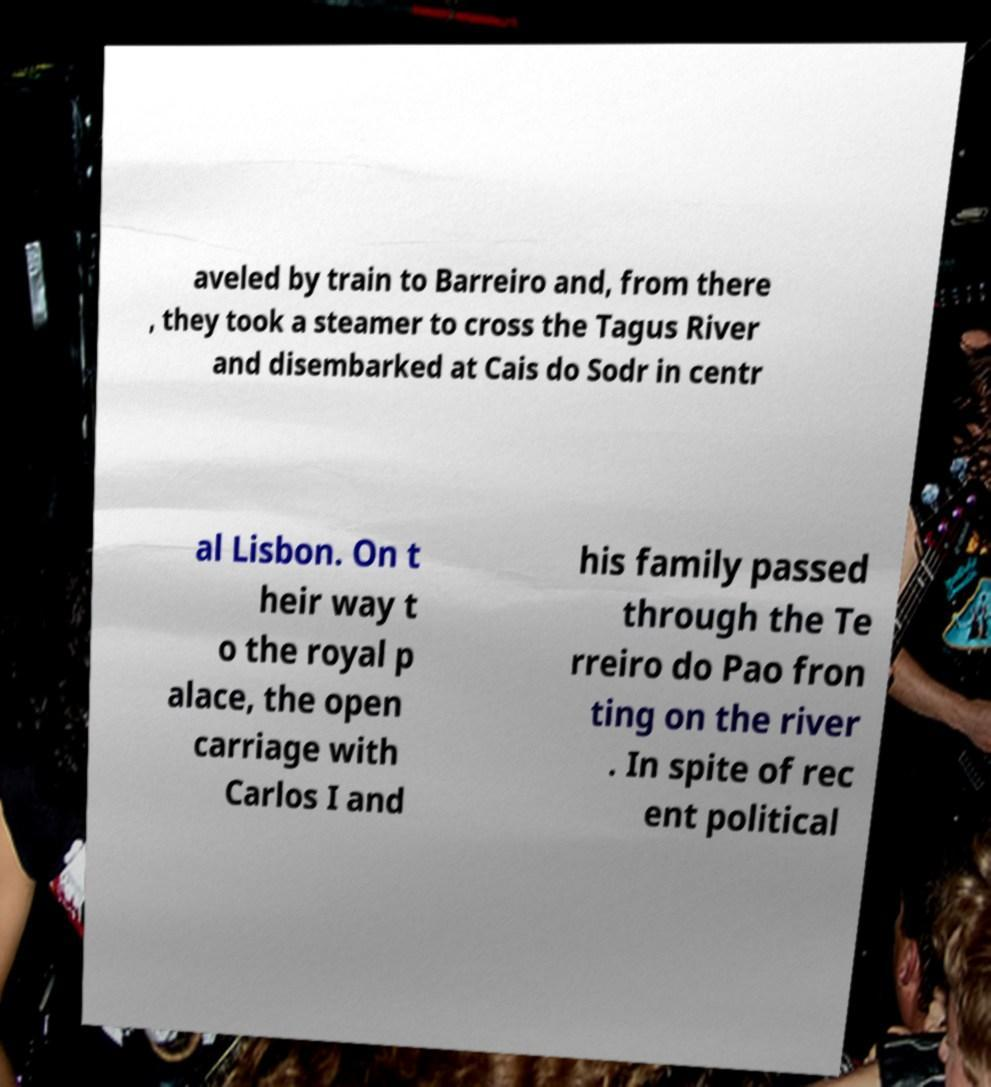Could you assist in decoding the text presented in this image and type it out clearly? aveled by train to Barreiro and, from there , they took a steamer to cross the Tagus River and disembarked at Cais do Sodr in centr al Lisbon. On t heir way t o the royal p alace, the open carriage with Carlos I and his family passed through the Te rreiro do Pao fron ting on the river . In spite of rec ent political 